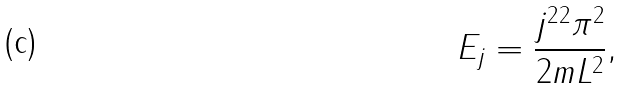Convert formula to latex. <formula><loc_0><loc_0><loc_500><loc_500>E _ { j } = \frac { j ^ { 2 } { } ^ { 2 } { \pi } ^ { 2 } } { 2 m L ^ { 2 } } ,</formula> 